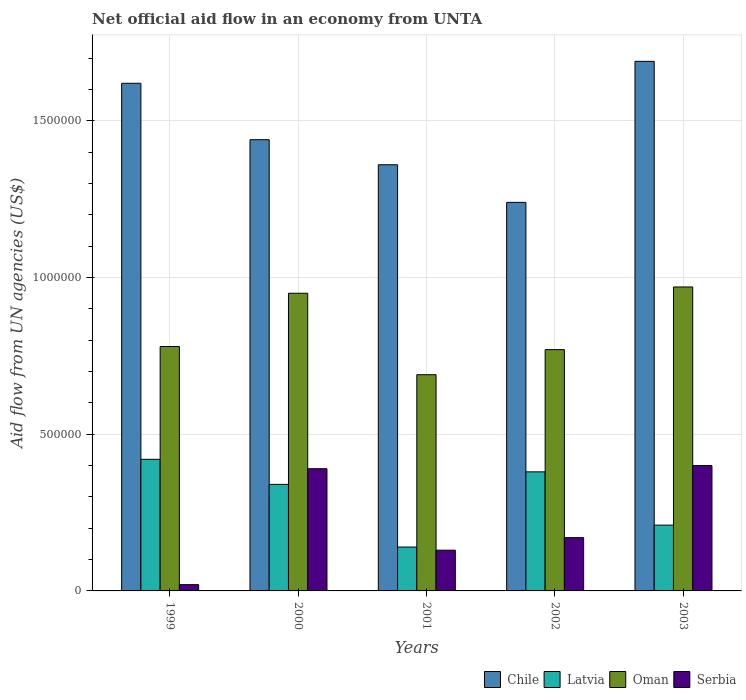How many groups of bars are there?
Provide a succinct answer. 5. Are the number of bars per tick equal to the number of legend labels?
Give a very brief answer. Yes. How many bars are there on the 4th tick from the right?
Provide a succinct answer. 4. In how many cases, is the number of bars for a given year not equal to the number of legend labels?
Ensure brevity in your answer.  0. What is the net official aid flow in Oman in 2001?
Offer a very short reply. 6.90e+05. Across all years, what is the minimum net official aid flow in Latvia?
Make the answer very short. 1.40e+05. In which year was the net official aid flow in Latvia minimum?
Provide a succinct answer. 2001. What is the total net official aid flow in Oman in the graph?
Ensure brevity in your answer.  4.16e+06. What is the difference between the net official aid flow in Serbia in 2000 and the net official aid flow in Chile in 2002?
Keep it short and to the point. -8.50e+05. What is the average net official aid flow in Latvia per year?
Make the answer very short. 2.98e+05. In the year 2000, what is the difference between the net official aid flow in Serbia and net official aid flow in Latvia?
Make the answer very short. 5.00e+04. What is the ratio of the net official aid flow in Chile in 2000 to that in 2003?
Offer a very short reply. 0.85. What is the difference between the highest and the second highest net official aid flow in Serbia?
Make the answer very short. 10000. What is the difference between the highest and the lowest net official aid flow in Chile?
Give a very brief answer. 4.50e+05. Is the sum of the net official aid flow in Oman in 1999 and 2000 greater than the maximum net official aid flow in Serbia across all years?
Offer a terse response. Yes. What does the 3rd bar from the left in 2002 represents?
Make the answer very short. Oman. What does the 2nd bar from the right in 2001 represents?
Offer a very short reply. Oman. Are all the bars in the graph horizontal?
Offer a terse response. No. How many years are there in the graph?
Make the answer very short. 5. Does the graph contain grids?
Your answer should be compact. Yes. Where does the legend appear in the graph?
Your answer should be very brief. Bottom right. How many legend labels are there?
Make the answer very short. 4. What is the title of the graph?
Give a very brief answer. Net official aid flow in an economy from UNTA. What is the label or title of the Y-axis?
Your answer should be very brief. Aid flow from UN agencies (US$). What is the Aid flow from UN agencies (US$) of Chile in 1999?
Offer a very short reply. 1.62e+06. What is the Aid flow from UN agencies (US$) of Oman in 1999?
Offer a terse response. 7.80e+05. What is the Aid flow from UN agencies (US$) of Chile in 2000?
Offer a very short reply. 1.44e+06. What is the Aid flow from UN agencies (US$) of Oman in 2000?
Ensure brevity in your answer.  9.50e+05. What is the Aid flow from UN agencies (US$) in Chile in 2001?
Provide a succinct answer. 1.36e+06. What is the Aid flow from UN agencies (US$) in Latvia in 2001?
Your answer should be very brief. 1.40e+05. What is the Aid flow from UN agencies (US$) of Oman in 2001?
Keep it short and to the point. 6.90e+05. What is the Aid flow from UN agencies (US$) of Chile in 2002?
Make the answer very short. 1.24e+06. What is the Aid flow from UN agencies (US$) in Latvia in 2002?
Your response must be concise. 3.80e+05. What is the Aid flow from UN agencies (US$) in Oman in 2002?
Keep it short and to the point. 7.70e+05. What is the Aid flow from UN agencies (US$) of Chile in 2003?
Ensure brevity in your answer.  1.69e+06. What is the Aid flow from UN agencies (US$) of Oman in 2003?
Ensure brevity in your answer.  9.70e+05. Across all years, what is the maximum Aid flow from UN agencies (US$) in Chile?
Give a very brief answer. 1.69e+06. Across all years, what is the maximum Aid flow from UN agencies (US$) of Latvia?
Give a very brief answer. 4.20e+05. Across all years, what is the maximum Aid flow from UN agencies (US$) of Oman?
Give a very brief answer. 9.70e+05. Across all years, what is the maximum Aid flow from UN agencies (US$) in Serbia?
Offer a terse response. 4.00e+05. Across all years, what is the minimum Aid flow from UN agencies (US$) of Chile?
Your answer should be compact. 1.24e+06. Across all years, what is the minimum Aid flow from UN agencies (US$) of Latvia?
Your answer should be very brief. 1.40e+05. Across all years, what is the minimum Aid flow from UN agencies (US$) of Oman?
Your answer should be very brief. 6.90e+05. What is the total Aid flow from UN agencies (US$) in Chile in the graph?
Your answer should be compact. 7.35e+06. What is the total Aid flow from UN agencies (US$) of Latvia in the graph?
Keep it short and to the point. 1.49e+06. What is the total Aid flow from UN agencies (US$) of Oman in the graph?
Offer a very short reply. 4.16e+06. What is the total Aid flow from UN agencies (US$) in Serbia in the graph?
Provide a succinct answer. 1.11e+06. What is the difference between the Aid flow from UN agencies (US$) in Chile in 1999 and that in 2000?
Your response must be concise. 1.80e+05. What is the difference between the Aid flow from UN agencies (US$) in Serbia in 1999 and that in 2000?
Your answer should be compact. -3.70e+05. What is the difference between the Aid flow from UN agencies (US$) in Chile in 1999 and that in 2001?
Your response must be concise. 2.60e+05. What is the difference between the Aid flow from UN agencies (US$) in Serbia in 1999 and that in 2001?
Offer a terse response. -1.10e+05. What is the difference between the Aid flow from UN agencies (US$) of Chile in 1999 and that in 2002?
Give a very brief answer. 3.80e+05. What is the difference between the Aid flow from UN agencies (US$) in Latvia in 1999 and that in 2002?
Ensure brevity in your answer.  4.00e+04. What is the difference between the Aid flow from UN agencies (US$) in Chile in 1999 and that in 2003?
Your answer should be very brief. -7.00e+04. What is the difference between the Aid flow from UN agencies (US$) in Serbia in 1999 and that in 2003?
Keep it short and to the point. -3.80e+05. What is the difference between the Aid flow from UN agencies (US$) in Oman in 2000 and that in 2001?
Keep it short and to the point. 2.60e+05. What is the difference between the Aid flow from UN agencies (US$) of Serbia in 2000 and that in 2001?
Offer a terse response. 2.60e+05. What is the difference between the Aid flow from UN agencies (US$) in Latvia in 2000 and that in 2002?
Offer a very short reply. -4.00e+04. What is the difference between the Aid flow from UN agencies (US$) of Oman in 2000 and that in 2002?
Keep it short and to the point. 1.80e+05. What is the difference between the Aid flow from UN agencies (US$) in Chile in 2000 and that in 2003?
Make the answer very short. -2.50e+05. What is the difference between the Aid flow from UN agencies (US$) in Serbia in 2000 and that in 2003?
Make the answer very short. -10000. What is the difference between the Aid flow from UN agencies (US$) of Latvia in 2001 and that in 2002?
Provide a succinct answer. -2.40e+05. What is the difference between the Aid flow from UN agencies (US$) of Oman in 2001 and that in 2002?
Your answer should be compact. -8.00e+04. What is the difference between the Aid flow from UN agencies (US$) in Serbia in 2001 and that in 2002?
Ensure brevity in your answer.  -4.00e+04. What is the difference between the Aid flow from UN agencies (US$) of Chile in 2001 and that in 2003?
Your response must be concise. -3.30e+05. What is the difference between the Aid flow from UN agencies (US$) in Latvia in 2001 and that in 2003?
Ensure brevity in your answer.  -7.00e+04. What is the difference between the Aid flow from UN agencies (US$) of Oman in 2001 and that in 2003?
Your answer should be very brief. -2.80e+05. What is the difference between the Aid flow from UN agencies (US$) of Chile in 2002 and that in 2003?
Offer a very short reply. -4.50e+05. What is the difference between the Aid flow from UN agencies (US$) of Latvia in 2002 and that in 2003?
Provide a short and direct response. 1.70e+05. What is the difference between the Aid flow from UN agencies (US$) of Serbia in 2002 and that in 2003?
Provide a short and direct response. -2.30e+05. What is the difference between the Aid flow from UN agencies (US$) of Chile in 1999 and the Aid flow from UN agencies (US$) of Latvia in 2000?
Your answer should be compact. 1.28e+06. What is the difference between the Aid flow from UN agencies (US$) in Chile in 1999 and the Aid flow from UN agencies (US$) in Oman in 2000?
Your response must be concise. 6.70e+05. What is the difference between the Aid flow from UN agencies (US$) in Chile in 1999 and the Aid flow from UN agencies (US$) in Serbia in 2000?
Offer a very short reply. 1.23e+06. What is the difference between the Aid flow from UN agencies (US$) in Latvia in 1999 and the Aid flow from UN agencies (US$) in Oman in 2000?
Keep it short and to the point. -5.30e+05. What is the difference between the Aid flow from UN agencies (US$) in Latvia in 1999 and the Aid flow from UN agencies (US$) in Serbia in 2000?
Your answer should be compact. 3.00e+04. What is the difference between the Aid flow from UN agencies (US$) in Oman in 1999 and the Aid flow from UN agencies (US$) in Serbia in 2000?
Your answer should be compact. 3.90e+05. What is the difference between the Aid flow from UN agencies (US$) of Chile in 1999 and the Aid flow from UN agencies (US$) of Latvia in 2001?
Give a very brief answer. 1.48e+06. What is the difference between the Aid flow from UN agencies (US$) in Chile in 1999 and the Aid flow from UN agencies (US$) in Oman in 2001?
Ensure brevity in your answer.  9.30e+05. What is the difference between the Aid flow from UN agencies (US$) in Chile in 1999 and the Aid flow from UN agencies (US$) in Serbia in 2001?
Your response must be concise. 1.49e+06. What is the difference between the Aid flow from UN agencies (US$) in Oman in 1999 and the Aid flow from UN agencies (US$) in Serbia in 2001?
Your answer should be very brief. 6.50e+05. What is the difference between the Aid flow from UN agencies (US$) of Chile in 1999 and the Aid flow from UN agencies (US$) of Latvia in 2002?
Give a very brief answer. 1.24e+06. What is the difference between the Aid flow from UN agencies (US$) in Chile in 1999 and the Aid flow from UN agencies (US$) in Oman in 2002?
Provide a succinct answer. 8.50e+05. What is the difference between the Aid flow from UN agencies (US$) of Chile in 1999 and the Aid flow from UN agencies (US$) of Serbia in 2002?
Give a very brief answer. 1.45e+06. What is the difference between the Aid flow from UN agencies (US$) of Latvia in 1999 and the Aid flow from UN agencies (US$) of Oman in 2002?
Your response must be concise. -3.50e+05. What is the difference between the Aid flow from UN agencies (US$) in Oman in 1999 and the Aid flow from UN agencies (US$) in Serbia in 2002?
Keep it short and to the point. 6.10e+05. What is the difference between the Aid flow from UN agencies (US$) of Chile in 1999 and the Aid flow from UN agencies (US$) of Latvia in 2003?
Your answer should be compact. 1.41e+06. What is the difference between the Aid flow from UN agencies (US$) in Chile in 1999 and the Aid flow from UN agencies (US$) in Oman in 2003?
Provide a succinct answer. 6.50e+05. What is the difference between the Aid flow from UN agencies (US$) of Chile in 1999 and the Aid flow from UN agencies (US$) of Serbia in 2003?
Ensure brevity in your answer.  1.22e+06. What is the difference between the Aid flow from UN agencies (US$) of Latvia in 1999 and the Aid flow from UN agencies (US$) of Oman in 2003?
Ensure brevity in your answer.  -5.50e+05. What is the difference between the Aid flow from UN agencies (US$) of Oman in 1999 and the Aid flow from UN agencies (US$) of Serbia in 2003?
Make the answer very short. 3.80e+05. What is the difference between the Aid flow from UN agencies (US$) in Chile in 2000 and the Aid flow from UN agencies (US$) in Latvia in 2001?
Provide a short and direct response. 1.30e+06. What is the difference between the Aid flow from UN agencies (US$) in Chile in 2000 and the Aid flow from UN agencies (US$) in Oman in 2001?
Offer a terse response. 7.50e+05. What is the difference between the Aid flow from UN agencies (US$) of Chile in 2000 and the Aid flow from UN agencies (US$) of Serbia in 2001?
Give a very brief answer. 1.31e+06. What is the difference between the Aid flow from UN agencies (US$) in Latvia in 2000 and the Aid flow from UN agencies (US$) in Oman in 2001?
Your response must be concise. -3.50e+05. What is the difference between the Aid flow from UN agencies (US$) of Latvia in 2000 and the Aid flow from UN agencies (US$) of Serbia in 2001?
Provide a succinct answer. 2.10e+05. What is the difference between the Aid flow from UN agencies (US$) of Oman in 2000 and the Aid flow from UN agencies (US$) of Serbia in 2001?
Your answer should be compact. 8.20e+05. What is the difference between the Aid flow from UN agencies (US$) of Chile in 2000 and the Aid flow from UN agencies (US$) of Latvia in 2002?
Your answer should be very brief. 1.06e+06. What is the difference between the Aid flow from UN agencies (US$) of Chile in 2000 and the Aid flow from UN agencies (US$) of Oman in 2002?
Provide a short and direct response. 6.70e+05. What is the difference between the Aid flow from UN agencies (US$) of Chile in 2000 and the Aid flow from UN agencies (US$) of Serbia in 2002?
Your answer should be compact. 1.27e+06. What is the difference between the Aid flow from UN agencies (US$) in Latvia in 2000 and the Aid flow from UN agencies (US$) in Oman in 2002?
Your answer should be compact. -4.30e+05. What is the difference between the Aid flow from UN agencies (US$) in Oman in 2000 and the Aid flow from UN agencies (US$) in Serbia in 2002?
Offer a very short reply. 7.80e+05. What is the difference between the Aid flow from UN agencies (US$) in Chile in 2000 and the Aid flow from UN agencies (US$) in Latvia in 2003?
Provide a short and direct response. 1.23e+06. What is the difference between the Aid flow from UN agencies (US$) in Chile in 2000 and the Aid flow from UN agencies (US$) in Oman in 2003?
Your response must be concise. 4.70e+05. What is the difference between the Aid flow from UN agencies (US$) of Chile in 2000 and the Aid flow from UN agencies (US$) of Serbia in 2003?
Offer a very short reply. 1.04e+06. What is the difference between the Aid flow from UN agencies (US$) of Latvia in 2000 and the Aid flow from UN agencies (US$) of Oman in 2003?
Give a very brief answer. -6.30e+05. What is the difference between the Aid flow from UN agencies (US$) of Latvia in 2000 and the Aid flow from UN agencies (US$) of Serbia in 2003?
Your answer should be compact. -6.00e+04. What is the difference between the Aid flow from UN agencies (US$) in Oman in 2000 and the Aid flow from UN agencies (US$) in Serbia in 2003?
Keep it short and to the point. 5.50e+05. What is the difference between the Aid flow from UN agencies (US$) of Chile in 2001 and the Aid flow from UN agencies (US$) of Latvia in 2002?
Your answer should be compact. 9.80e+05. What is the difference between the Aid flow from UN agencies (US$) of Chile in 2001 and the Aid flow from UN agencies (US$) of Oman in 2002?
Your answer should be compact. 5.90e+05. What is the difference between the Aid flow from UN agencies (US$) of Chile in 2001 and the Aid flow from UN agencies (US$) of Serbia in 2002?
Your answer should be compact. 1.19e+06. What is the difference between the Aid flow from UN agencies (US$) in Latvia in 2001 and the Aid flow from UN agencies (US$) in Oman in 2002?
Provide a short and direct response. -6.30e+05. What is the difference between the Aid flow from UN agencies (US$) in Latvia in 2001 and the Aid flow from UN agencies (US$) in Serbia in 2002?
Your answer should be compact. -3.00e+04. What is the difference between the Aid flow from UN agencies (US$) of Oman in 2001 and the Aid flow from UN agencies (US$) of Serbia in 2002?
Your answer should be very brief. 5.20e+05. What is the difference between the Aid flow from UN agencies (US$) in Chile in 2001 and the Aid flow from UN agencies (US$) in Latvia in 2003?
Your response must be concise. 1.15e+06. What is the difference between the Aid flow from UN agencies (US$) in Chile in 2001 and the Aid flow from UN agencies (US$) in Serbia in 2003?
Offer a very short reply. 9.60e+05. What is the difference between the Aid flow from UN agencies (US$) in Latvia in 2001 and the Aid flow from UN agencies (US$) in Oman in 2003?
Your answer should be very brief. -8.30e+05. What is the difference between the Aid flow from UN agencies (US$) of Latvia in 2001 and the Aid flow from UN agencies (US$) of Serbia in 2003?
Ensure brevity in your answer.  -2.60e+05. What is the difference between the Aid flow from UN agencies (US$) in Chile in 2002 and the Aid flow from UN agencies (US$) in Latvia in 2003?
Provide a succinct answer. 1.03e+06. What is the difference between the Aid flow from UN agencies (US$) of Chile in 2002 and the Aid flow from UN agencies (US$) of Serbia in 2003?
Your answer should be very brief. 8.40e+05. What is the difference between the Aid flow from UN agencies (US$) in Latvia in 2002 and the Aid flow from UN agencies (US$) in Oman in 2003?
Provide a succinct answer. -5.90e+05. What is the difference between the Aid flow from UN agencies (US$) of Latvia in 2002 and the Aid flow from UN agencies (US$) of Serbia in 2003?
Provide a short and direct response. -2.00e+04. What is the difference between the Aid flow from UN agencies (US$) of Oman in 2002 and the Aid flow from UN agencies (US$) of Serbia in 2003?
Make the answer very short. 3.70e+05. What is the average Aid flow from UN agencies (US$) of Chile per year?
Offer a very short reply. 1.47e+06. What is the average Aid flow from UN agencies (US$) of Latvia per year?
Make the answer very short. 2.98e+05. What is the average Aid flow from UN agencies (US$) in Oman per year?
Offer a very short reply. 8.32e+05. What is the average Aid flow from UN agencies (US$) of Serbia per year?
Offer a terse response. 2.22e+05. In the year 1999, what is the difference between the Aid flow from UN agencies (US$) in Chile and Aid flow from UN agencies (US$) in Latvia?
Keep it short and to the point. 1.20e+06. In the year 1999, what is the difference between the Aid flow from UN agencies (US$) in Chile and Aid flow from UN agencies (US$) in Oman?
Give a very brief answer. 8.40e+05. In the year 1999, what is the difference between the Aid flow from UN agencies (US$) of Chile and Aid flow from UN agencies (US$) of Serbia?
Provide a short and direct response. 1.60e+06. In the year 1999, what is the difference between the Aid flow from UN agencies (US$) of Latvia and Aid flow from UN agencies (US$) of Oman?
Provide a short and direct response. -3.60e+05. In the year 1999, what is the difference between the Aid flow from UN agencies (US$) of Latvia and Aid flow from UN agencies (US$) of Serbia?
Keep it short and to the point. 4.00e+05. In the year 1999, what is the difference between the Aid flow from UN agencies (US$) of Oman and Aid flow from UN agencies (US$) of Serbia?
Keep it short and to the point. 7.60e+05. In the year 2000, what is the difference between the Aid flow from UN agencies (US$) in Chile and Aid flow from UN agencies (US$) in Latvia?
Keep it short and to the point. 1.10e+06. In the year 2000, what is the difference between the Aid flow from UN agencies (US$) of Chile and Aid flow from UN agencies (US$) of Serbia?
Offer a terse response. 1.05e+06. In the year 2000, what is the difference between the Aid flow from UN agencies (US$) of Latvia and Aid flow from UN agencies (US$) of Oman?
Provide a succinct answer. -6.10e+05. In the year 2000, what is the difference between the Aid flow from UN agencies (US$) of Oman and Aid flow from UN agencies (US$) of Serbia?
Offer a terse response. 5.60e+05. In the year 2001, what is the difference between the Aid flow from UN agencies (US$) of Chile and Aid flow from UN agencies (US$) of Latvia?
Make the answer very short. 1.22e+06. In the year 2001, what is the difference between the Aid flow from UN agencies (US$) in Chile and Aid flow from UN agencies (US$) in Oman?
Provide a succinct answer. 6.70e+05. In the year 2001, what is the difference between the Aid flow from UN agencies (US$) of Chile and Aid flow from UN agencies (US$) of Serbia?
Give a very brief answer. 1.23e+06. In the year 2001, what is the difference between the Aid flow from UN agencies (US$) of Latvia and Aid flow from UN agencies (US$) of Oman?
Ensure brevity in your answer.  -5.50e+05. In the year 2001, what is the difference between the Aid flow from UN agencies (US$) in Latvia and Aid flow from UN agencies (US$) in Serbia?
Your response must be concise. 10000. In the year 2001, what is the difference between the Aid flow from UN agencies (US$) of Oman and Aid flow from UN agencies (US$) of Serbia?
Your answer should be compact. 5.60e+05. In the year 2002, what is the difference between the Aid flow from UN agencies (US$) of Chile and Aid flow from UN agencies (US$) of Latvia?
Provide a short and direct response. 8.60e+05. In the year 2002, what is the difference between the Aid flow from UN agencies (US$) in Chile and Aid flow from UN agencies (US$) in Serbia?
Give a very brief answer. 1.07e+06. In the year 2002, what is the difference between the Aid flow from UN agencies (US$) in Latvia and Aid flow from UN agencies (US$) in Oman?
Your answer should be compact. -3.90e+05. In the year 2002, what is the difference between the Aid flow from UN agencies (US$) of Latvia and Aid flow from UN agencies (US$) of Serbia?
Give a very brief answer. 2.10e+05. In the year 2003, what is the difference between the Aid flow from UN agencies (US$) of Chile and Aid flow from UN agencies (US$) of Latvia?
Keep it short and to the point. 1.48e+06. In the year 2003, what is the difference between the Aid flow from UN agencies (US$) of Chile and Aid flow from UN agencies (US$) of Oman?
Make the answer very short. 7.20e+05. In the year 2003, what is the difference between the Aid flow from UN agencies (US$) of Chile and Aid flow from UN agencies (US$) of Serbia?
Provide a short and direct response. 1.29e+06. In the year 2003, what is the difference between the Aid flow from UN agencies (US$) of Latvia and Aid flow from UN agencies (US$) of Oman?
Offer a terse response. -7.60e+05. In the year 2003, what is the difference between the Aid flow from UN agencies (US$) of Oman and Aid flow from UN agencies (US$) of Serbia?
Give a very brief answer. 5.70e+05. What is the ratio of the Aid flow from UN agencies (US$) in Chile in 1999 to that in 2000?
Offer a very short reply. 1.12. What is the ratio of the Aid flow from UN agencies (US$) in Latvia in 1999 to that in 2000?
Your answer should be compact. 1.24. What is the ratio of the Aid flow from UN agencies (US$) of Oman in 1999 to that in 2000?
Make the answer very short. 0.82. What is the ratio of the Aid flow from UN agencies (US$) in Serbia in 1999 to that in 2000?
Your response must be concise. 0.05. What is the ratio of the Aid flow from UN agencies (US$) of Chile in 1999 to that in 2001?
Your answer should be compact. 1.19. What is the ratio of the Aid flow from UN agencies (US$) of Oman in 1999 to that in 2001?
Provide a succinct answer. 1.13. What is the ratio of the Aid flow from UN agencies (US$) of Serbia in 1999 to that in 2001?
Make the answer very short. 0.15. What is the ratio of the Aid flow from UN agencies (US$) in Chile in 1999 to that in 2002?
Ensure brevity in your answer.  1.31. What is the ratio of the Aid flow from UN agencies (US$) in Latvia in 1999 to that in 2002?
Provide a short and direct response. 1.11. What is the ratio of the Aid flow from UN agencies (US$) in Serbia in 1999 to that in 2002?
Your response must be concise. 0.12. What is the ratio of the Aid flow from UN agencies (US$) in Chile in 1999 to that in 2003?
Your response must be concise. 0.96. What is the ratio of the Aid flow from UN agencies (US$) of Oman in 1999 to that in 2003?
Offer a terse response. 0.8. What is the ratio of the Aid flow from UN agencies (US$) in Serbia in 1999 to that in 2003?
Offer a terse response. 0.05. What is the ratio of the Aid flow from UN agencies (US$) in Chile in 2000 to that in 2001?
Make the answer very short. 1.06. What is the ratio of the Aid flow from UN agencies (US$) of Latvia in 2000 to that in 2001?
Your answer should be compact. 2.43. What is the ratio of the Aid flow from UN agencies (US$) of Oman in 2000 to that in 2001?
Your response must be concise. 1.38. What is the ratio of the Aid flow from UN agencies (US$) in Chile in 2000 to that in 2002?
Your response must be concise. 1.16. What is the ratio of the Aid flow from UN agencies (US$) in Latvia in 2000 to that in 2002?
Give a very brief answer. 0.89. What is the ratio of the Aid flow from UN agencies (US$) in Oman in 2000 to that in 2002?
Make the answer very short. 1.23. What is the ratio of the Aid flow from UN agencies (US$) of Serbia in 2000 to that in 2002?
Your answer should be compact. 2.29. What is the ratio of the Aid flow from UN agencies (US$) of Chile in 2000 to that in 2003?
Offer a very short reply. 0.85. What is the ratio of the Aid flow from UN agencies (US$) in Latvia in 2000 to that in 2003?
Ensure brevity in your answer.  1.62. What is the ratio of the Aid flow from UN agencies (US$) in Oman in 2000 to that in 2003?
Your answer should be very brief. 0.98. What is the ratio of the Aid flow from UN agencies (US$) in Chile in 2001 to that in 2002?
Make the answer very short. 1.1. What is the ratio of the Aid flow from UN agencies (US$) in Latvia in 2001 to that in 2002?
Your answer should be very brief. 0.37. What is the ratio of the Aid flow from UN agencies (US$) in Oman in 2001 to that in 2002?
Your answer should be compact. 0.9. What is the ratio of the Aid flow from UN agencies (US$) in Serbia in 2001 to that in 2002?
Your response must be concise. 0.76. What is the ratio of the Aid flow from UN agencies (US$) of Chile in 2001 to that in 2003?
Ensure brevity in your answer.  0.8. What is the ratio of the Aid flow from UN agencies (US$) in Latvia in 2001 to that in 2003?
Ensure brevity in your answer.  0.67. What is the ratio of the Aid flow from UN agencies (US$) in Oman in 2001 to that in 2003?
Give a very brief answer. 0.71. What is the ratio of the Aid flow from UN agencies (US$) in Serbia in 2001 to that in 2003?
Offer a terse response. 0.33. What is the ratio of the Aid flow from UN agencies (US$) in Chile in 2002 to that in 2003?
Give a very brief answer. 0.73. What is the ratio of the Aid flow from UN agencies (US$) of Latvia in 2002 to that in 2003?
Offer a very short reply. 1.81. What is the ratio of the Aid flow from UN agencies (US$) in Oman in 2002 to that in 2003?
Ensure brevity in your answer.  0.79. What is the ratio of the Aid flow from UN agencies (US$) in Serbia in 2002 to that in 2003?
Your response must be concise. 0.42. What is the difference between the highest and the second highest Aid flow from UN agencies (US$) of Chile?
Give a very brief answer. 7.00e+04. What is the difference between the highest and the second highest Aid flow from UN agencies (US$) in Latvia?
Offer a terse response. 4.00e+04. What is the difference between the highest and the second highest Aid flow from UN agencies (US$) of Serbia?
Your answer should be compact. 10000. What is the difference between the highest and the lowest Aid flow from UN agencies (US$) in Chile?
Offer a terse response. 4.50e+05. 